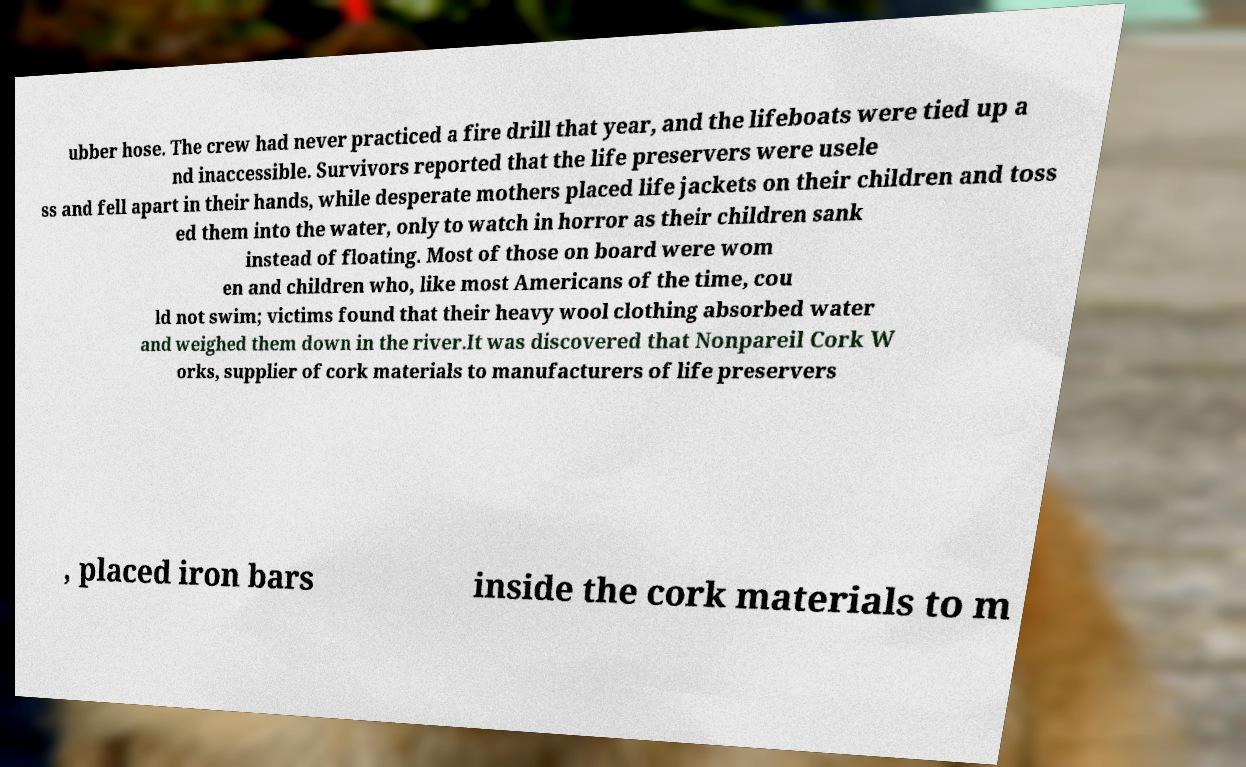Could you extract and type out the text from this image? ubber hose. The crew had never practiced a fire drill that year, and the lifeboats were tied up a nd inaccessible. Survivors reported that the life preservers were usele ss and fell apart in their hands, while desperate mothers placed life jackets on their children and toss ed them into the water, only to watch in horror as their children sank instead of floating. Most of those on board were wom en and children who, like most Americans of the time, cou ld not swim; victims found that their heavy wool clothing absorbed water and weighed them down in the river.It was discovered that Nonpareil Cork W orks, supplier of cork materials to manufacturers of life preservers , placed iron bars inside the cork materials to m 